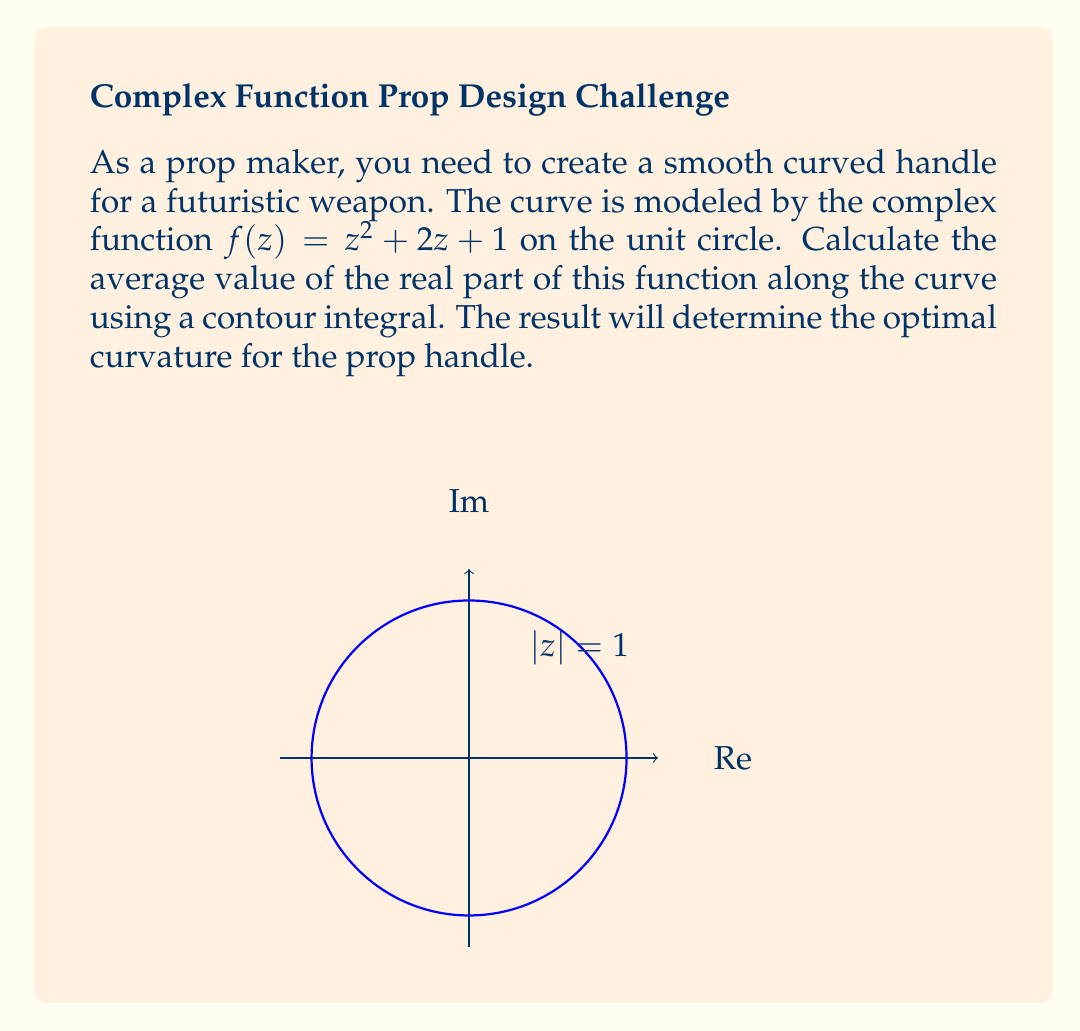Provide a solution to this math problem. Let's approach this step-by-step:

1) The average value of a function $f(z)$ along a curve $C$ is given by:

   $$\frac{1}{L}\int_C f(z) dz$$

   where $L$ is the length of the curve.

2) In our case, $C$ is the unit circle, so $L = 2\pi$. We only need the real part, so our integral becomes:

   $$\frac{1}{2\pi}\int_{|z|=1} \text{Re}(z^2 + 2z + 1) dz$$

3) On the unit circle, we can parameterize $z$ as $e^{i\theta}$, where $0 \leq \theta < 2\pi$. Then $dz = ie^{i\theta}d\theta$.

4) Substituting:

   $$\frac{1}{2\pi}\int_0^{2\pi} \text{Re}((e^{i\theta})^2 + 2e^{i\theta} + 1) ie^{i\theta}d\theta$$

5) Simplify inside the integral:

   $$\frac{1}{2\pi}\int_0^{2\pi} \text{Re}(e^{2i\theta} + 2e^{i\theta} + 1) ie^{i\theta}d\theta$$

6) The real part of $e^{2i\theta} + 2e^{i\theta} + 1$ is $\cos(2\theta) + 2\cos(\theta) + 1$

7) Our integral becomes:

   $$\frac{1}{2\pi}\int_0^{2\pi} (\cos(2\theta) + 2\cos(\theta) + 1) ie^{i\theta}d\theta$$

8) Expand $ie^{i\theta} = i(\cos(\theta) + i\sin(\theta)) = -\sin(\theta) + i\cos(\theta)$

9) We only need the real part, so our integral simplifies to:

   $$\frac{1}{2\pi}\int_0^{2\pi} (\cos(2\theta) + 2\cos(\theta) + 1) (-\sin(\theta)) d\theta$$

10) Integrate term by term:

    $$\frac{1}{2\pi}[-\frac{1}{3}\cos(3\theta) + \frac{1}{3}\cos(\theta) - 2\sin(\theta) - \theta]_0^{2\pi}$$

11) Evaluate the definite integral:

    $$\frac{1}{2\pi}[0 + 0 - 0 - 2\pi] = -1$$

Therefore, the average value of the real part of $f(z)$ along the unit circle is -1.
Answer: $-1$ 